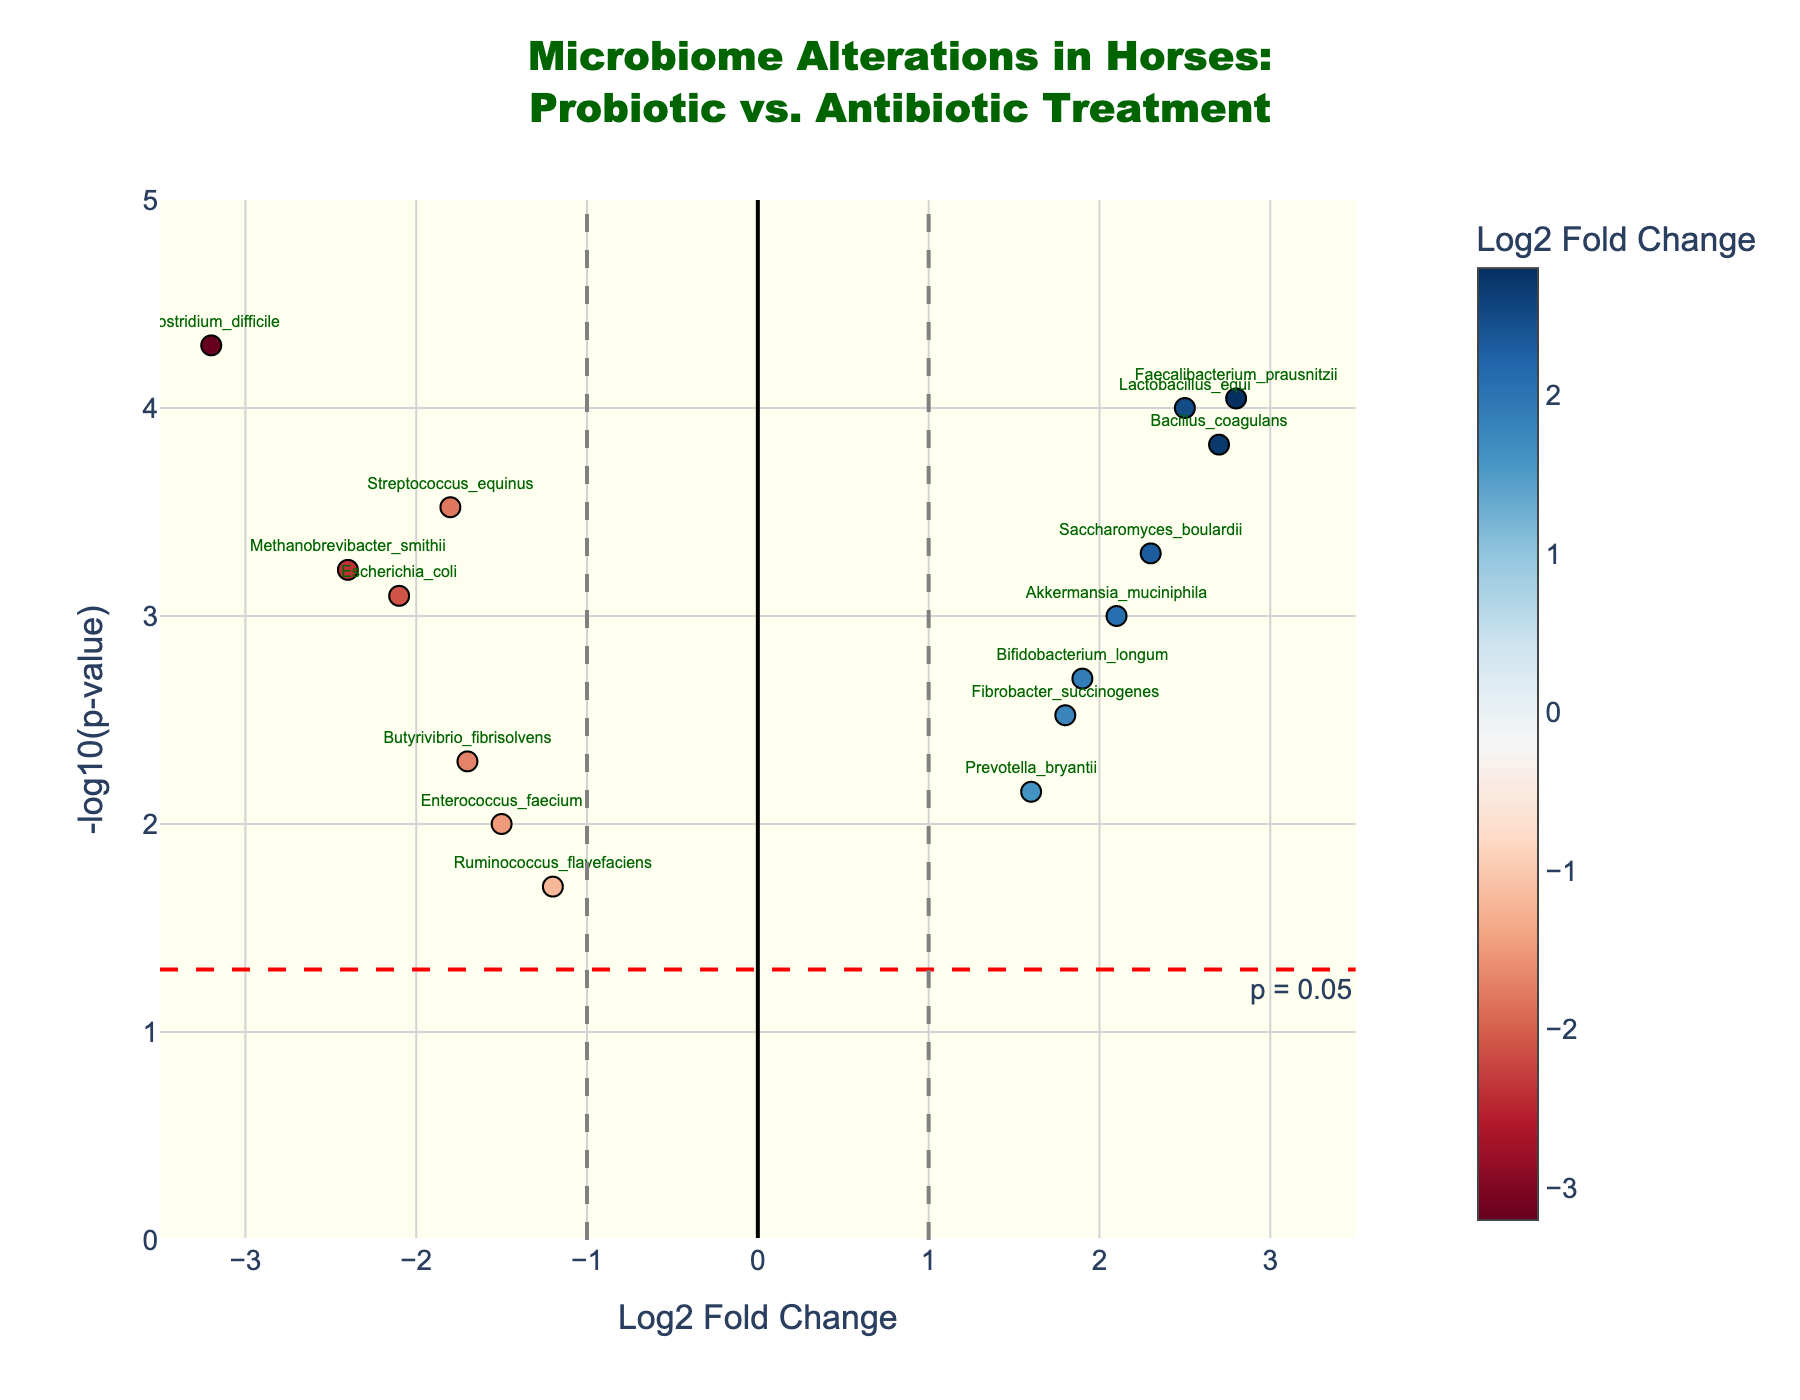What is the title of the figure? The title of the figure is usually found at the top of the plot. In this case, the title reads "Microbiome Alterations in Horses: Probiotic vs. Antibiotic Treatment".
Answer: Microbiome Alterations in Horses: Probiotic vs. Antibiotic Treatment What do the colors of the points represent in this Volcano Plot? The colors of the points on the Volcano Plot represent the Log2 Fold Change, as indicated by the color bar titled "Log2 Fold Change" on the right of the plot.
Answer: Log2 Fold Change Which gene has the highest Log2 Fold Change? The gene with the highest value on the x-axis of the plot is Faecalibacterium_prausnitzii with a Log2 Fold Change of 2.8, positioned furthest to the right.
Answer: Faecalibacterium_prausnitzii What does a point above the red dashed horizontal line represent? Points above the red dashed line indicate genes with a p-value less than 0.05 as the line represents the threshold for p-value significance.
Answer: Genes with p-value < 0.05 How many genes show a statistically significant increase in abundance? Statistically significant genes have a p-value < 0.05 (above the red line) and positive Log2 Fold Change (right of the vertical line at x=1). All genes right of the red line are: Lactobacillus_equi, Bacillus_coagulans, Saccharomyces_boulardii, Akkermansia_muciniphila, Faecalibacterium_prausnitzii. Count of these genes is 5.
Answer: 5 Compare Lactobacillus_equi and Clostridium_difficile in terms of their Log2 Fold Change and significance. Lactobacillus_equi has a Log2 Fold Change of 2.5 and Clostridium_difficile has -3.2. Both are above the red horizontal line indicating a p-value < 0.05, so both are statistically significant but in different directions (increase vs. decrease).
Answer: Lactobacillus_equi increased and Clostridium_difficile decreased, both significant Which genes decreased in abundance following probiotic therapy? Genes with negative Log2 Fold Change values are indicative of a decrease. These include Streptococcus_equinus, Clostridium_difficile, Escherichia_coli, Enterococcus_faecium, Ruminococcus_flavefaciens, Methanobrevibacter_smithii, Butyrivibrio_fibrisolvens.
Answer: 7 genes Which gene has the lowest (most negative) Log2 Fold Change and what is its significance level? Clostridium_difficile has the most negative Log2 Fold Change (-3.2), and it is far above the red horizontal threshold line indicating high significance, with a p-value of 0.00005.
Answer: Clostridium_difficile, p-value of 0.00005 Based on the figure, which therapeutic treatment (probiotic or antibiotic) seems to have a more significant effect on microbiome alterations in horses? Most points either showing significant increases or decreases fall well beyond the significance threshold (red line). These alterations suggest the probiotic (most increased genes) and antibiotic (most decreased genes) treatments have significant impacts on different aspects of the microbiome.
Answer: Both have significant effects 